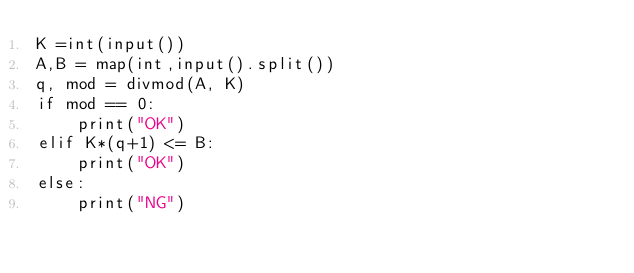<code> <loc_0><loc_0><loc_500><loc_500><_Python_>K =int(input())
A,B = map(int,input().split())
q, mod = divmod(A, K)
if mod == 0:
    print("OK")
elif K*(q+1) <= B:
    print("OK")
else:
    print("NG")</code> 